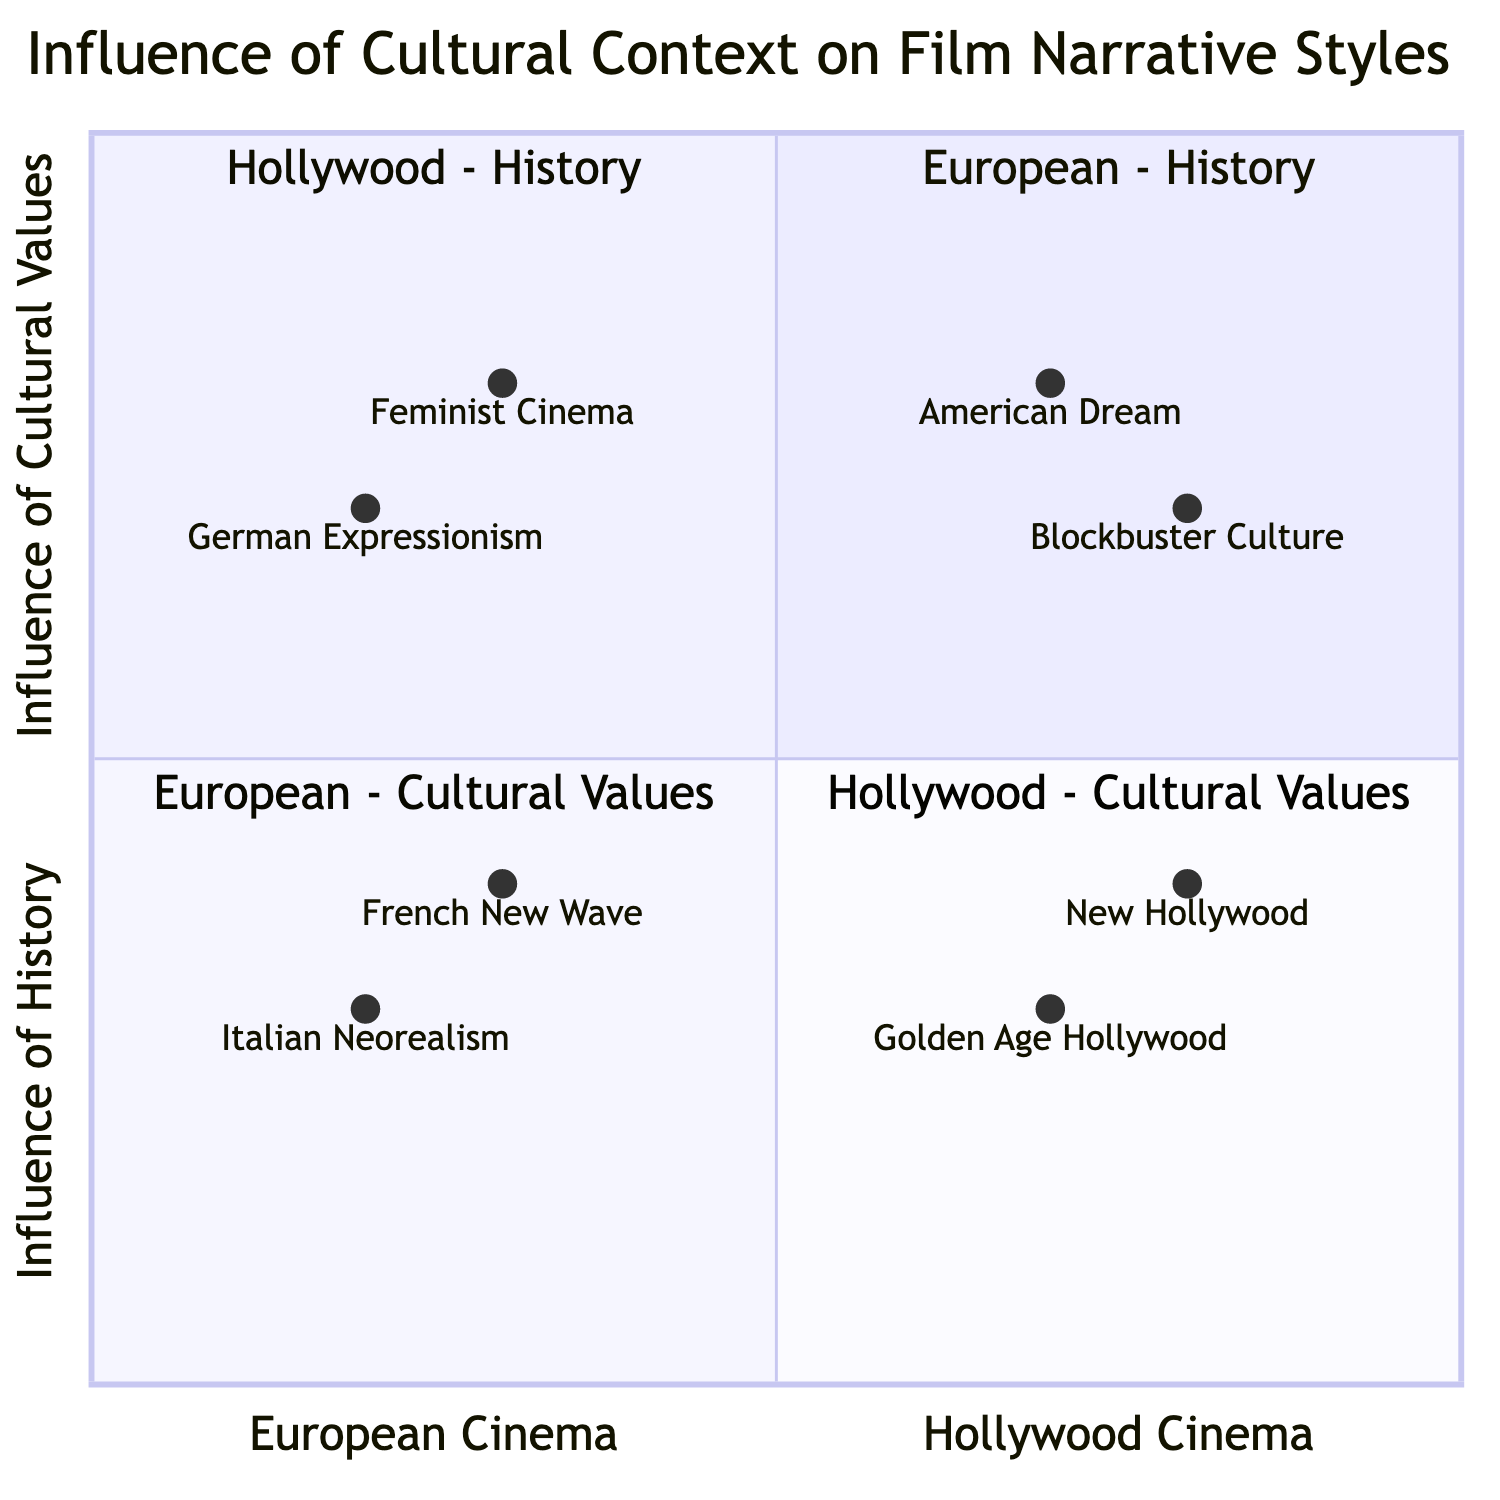What element represents European cinema influenced by history? The diagram shows two elements in the "European Cinema - Influence of History" quadrant: Italian Neorealism and French New Wave. Since both are present, either could answer the question, but the first listed element is Italian Neorealism.
Answer: Italian Neorealism Which quadrant contains American Dream? The American Dream is located in the "Hollywood Cinema - Influence of Cultural Values" quadrant. By locating the element labeled American Dream within the corresponding quadrant, the answer is derived.
Answer: Hollywood Cinema - Influence of Cultural Values How many elements are in the quadrant for European Cinema - Influence of Cultural Values? The "European Cinema - Influence of Cultural Values" quadrant contains two elements: German Expressionism and Feminist Cinema. Counting these elements provides the total number.
Answer: 2 Which Hollywood narrative style emerged during the Golden Age? The Golden Age Hollywood is characterized by star-driven narratives and escapism during significant historical events like the Great Depression and WWII. This information is derived directly from its description.
Answer: Star-driven narratives Name one influence that Italian Neorealism focuses on. According to the diagram, Italian Neorealism focuses on everyday life, particularly reflecting the post-WWII context. The description in the quadrant confirms this primary influence.
Answer: Everyday life Which cinematic movement emphasizes personal expression and experimentation? The description associated with French New Wave indicates that it emphasizes personal expression and experimentation, making it a defining feature of this film movement.
Answer: French New Wave What cultural value influences the narratives focusing on aspiration in Hollywood cinema? The diagram indicates that the "American Dream" is the cultural value that influences narratives about aspiration and individual success in Hollywood cinema, as noted in its description.
Answer: American Dream Which quadrant contains both German Expressionism and Feminist Cinema? The "European Cinema - Influence of Cultural Values" quadrant contains both German Expressionism and Feminist Cinema. Locating these elements confirms their shared quadrant.
Answer: European Cinema - Influence of Cultural Values What is the primary focus of Blockbuster Culture in Hollywood? The description for Blockbuster Culture states it emphasizes high production values and special effects, which are key elements of its focus as indicated in the diagram.
Answer: High production values and special effects 